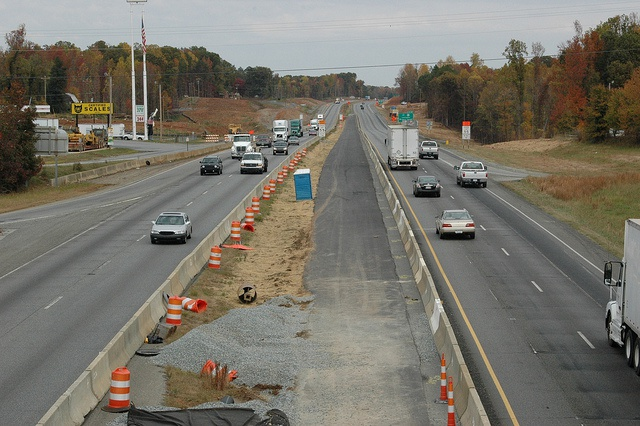Describe the objects in this image and their specific colors. I can see truck in lightgray, darkgray, black, and gray tones, truck in lightgray, darkgray, gray, and black tones, car in lightgray, gray, black, and darkgray tones, car in lightgray, darkgray, gray, and black tones, and truck in lightgray, gray, darkgray, and black tones in this image. 